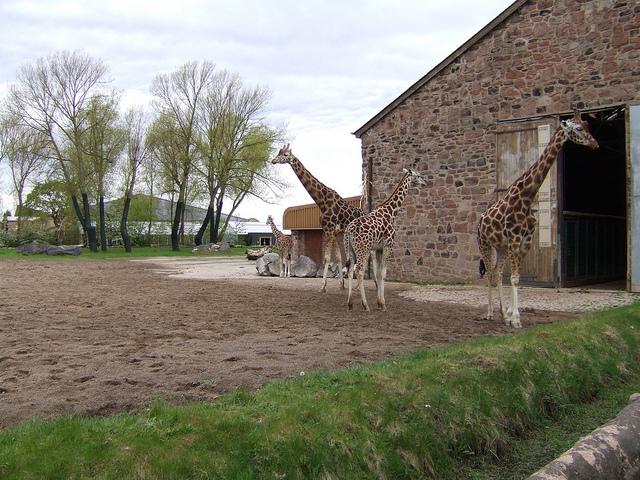Why is there a size difference between the two animals?
Concise answer only. Age. IS this in color?
Short answer required. Yes. Are both animals in this picture giraffes?
Be succinct. Yes. What kind of weather is featured in the picture?
Give a very brief answer. Cloudy. How many windows are in the top of the building?
Quick response, please. 0. How many giraffes are shown?
Give a very brief answer. 4. Do these animals have shelter from the elements?
Quick response, please. Yes. What direction are the giraffes facing?
Quick response, please. Different. 